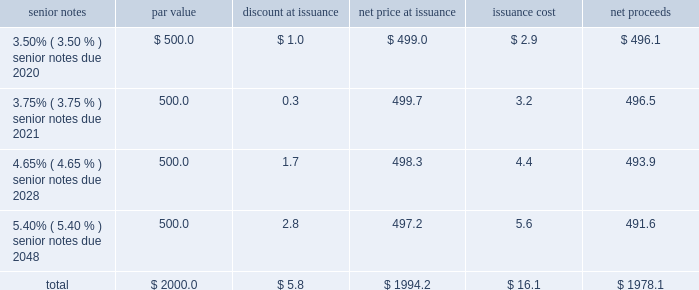Notes to consolidated financial statements 2013 ( continued ) ( amounts in millions , except per share amounts ) debt transactions see note 6 for further information regarding the company 2019s acquisition of acxiom ( the 201cacxiom acquisition 201d ) on october 1 , 2018 ( the 201cclosing date 201d ) .
Senior notes on september 21 , 2018 , in order to fund the acxiom acquisition and related fees and expenses , we issued a total of $ 2000.0 in aggregate principal amount of unsecured senior notes ( in four separate series of $ 500.0 each , together , the 201csenior notes 201d ) .
Upon issuance , the senior notes were reflected on our consolidated balance sheets net of discount of $ 5.8 and net of the capitalized debt issuance costs , including commissions and offering expenses of $ 16.1 , both of which will be amortized in interest expense through the respective maturity dates of each series of senior notes using the effective interest method .
Interest is payable semi-annually in arrears on april 1st and october 1st of each year , commencing on april 1 , 2019 .
The issuance was comprised of the following four series of notes : senior notes par value discount at issuance net price at issuance issuance cost net proceeds .
Consistent with our other debt securities , the newly issued senior notes include covenants that , among other things , limit our liens and the liens of certain of our consolidated subsidiaries , but do not require us to maintain any financial ratios or specified levels of net worth or liquidity .
We may redeem each series of the senior notes at any time in whole or from time to time in part in accordance with the provisions of the indenture , including the applicable supplemental indenture , under which such series of senior notes was issued .
If the acxiom acquisition had been terminated or had not closed on or prior to june 30 , 2019 , we would have been required to redeem the senior notes due 2020 , 2021 and 2028 at a redemption price equal to 101% ( 101 % ) of the principal amount thereof , plus accrued and unpaid interest .
Additionally , upon the occurrence of a change of control repurchase event with respect to the senior notes , each holder of the senior notes has the right to require the company to purchase that holder 2019s senior notes at a price equal to 101% ( 101 % ) of the principal amount thereof , plus accrued and unpaid interest , unless the company has exercised its option to redeem all the senior notes .
Term loan agreement on october 1 , 2018 , in order to fund the acxiom acquisition and related fees and expenses , we borrowed $ 500.0 through debt financing arrangements with third-party lenders under a three-year term loan agreement ( the 201cterm loan agreement 201d ) , $ 100.0 of which we paid down on december 3 , 2018 .
Consistent with our other debt securities , the term loan agreement includes covenants that , among other things , limit our liens and the liens of certain of our consolidated subsidiaries .
In addition , it requires us to maintain the same financial maintenance covenants as discussed below .
Loans under the term loan bear interest at a variable rate based on , at the company 2019s option , either the base rate or the eurodollar rate ( each as defined in the term loan agreement ) plus an applicable margin that is determined based on our credit ratings .
As of december 31 , 2018 , the applicable margin was 0.25% ( 0.25 % ) for base rate loans and 1.25% ( 1.25 % ) for eurodollar rate loans. .
What was the percentage of issuance costs attributable to the senior notes due 2021? 
Computations: (3.2 / 16.1)
Answer: 0.19876. 